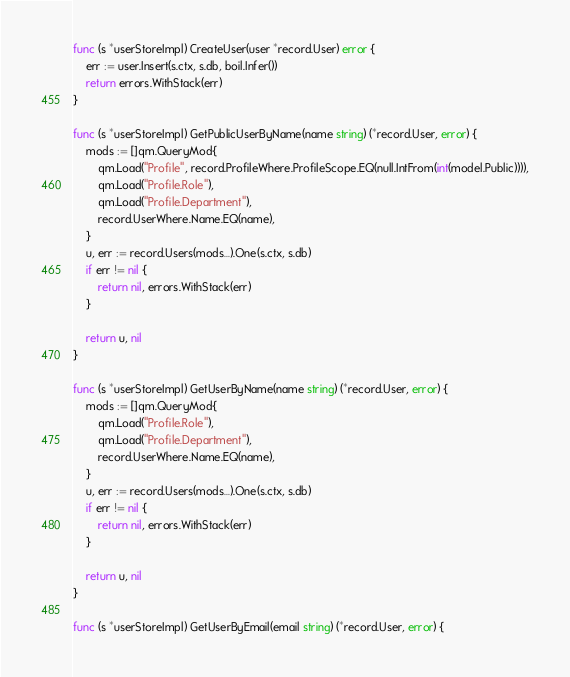Convert code to text. <code><loc_0><loc_0><loc_500><loc_500><_Go_>
func (s *userStoreImpl) CreateUser(user *record.User) error {
	err := user.Insert(s.ctx, s.db, boil.Infer())
	return errors.WithStack(err)
}

func (s *userStoreImpl) GetPublicUserByName(name string) (*record.User, error) {
	mods := []qm.QueryMod{
		qm.Load("Profile", record.ProfileWhere.ProfileScope.EQ(null.IntFrom(int(model.Public)))),
		qm.Load("Profile.Role"),
		qm.Load("Profile.Department"),
		record.UserWhere.Name.EQ(name),
	}
	u, err := record.Users(mods...).One(s.ctx, s.db)
	if err != nil {
		return nil, errors.WithStack(err)
	}

	return u, nil
}

func (s *userStoreImpl) GetUserByName(name string) (*record.User, error) {
	mods := []qm.QueryMod{
		qm.Load("Profile.Role"),
		qm.Load("Profile.Department"),
		record.UserWhere.Name.EQ(name),
	}
	u, err := record.Users(mods...).One(s.ctx, s.db)
	if err != nil {
		return nil, errors.WithStack(err)
	}

	return u, nil
}

func (s *userStoreImpl) GetUserByEmail(email string) (*record.User, error) {</code> 